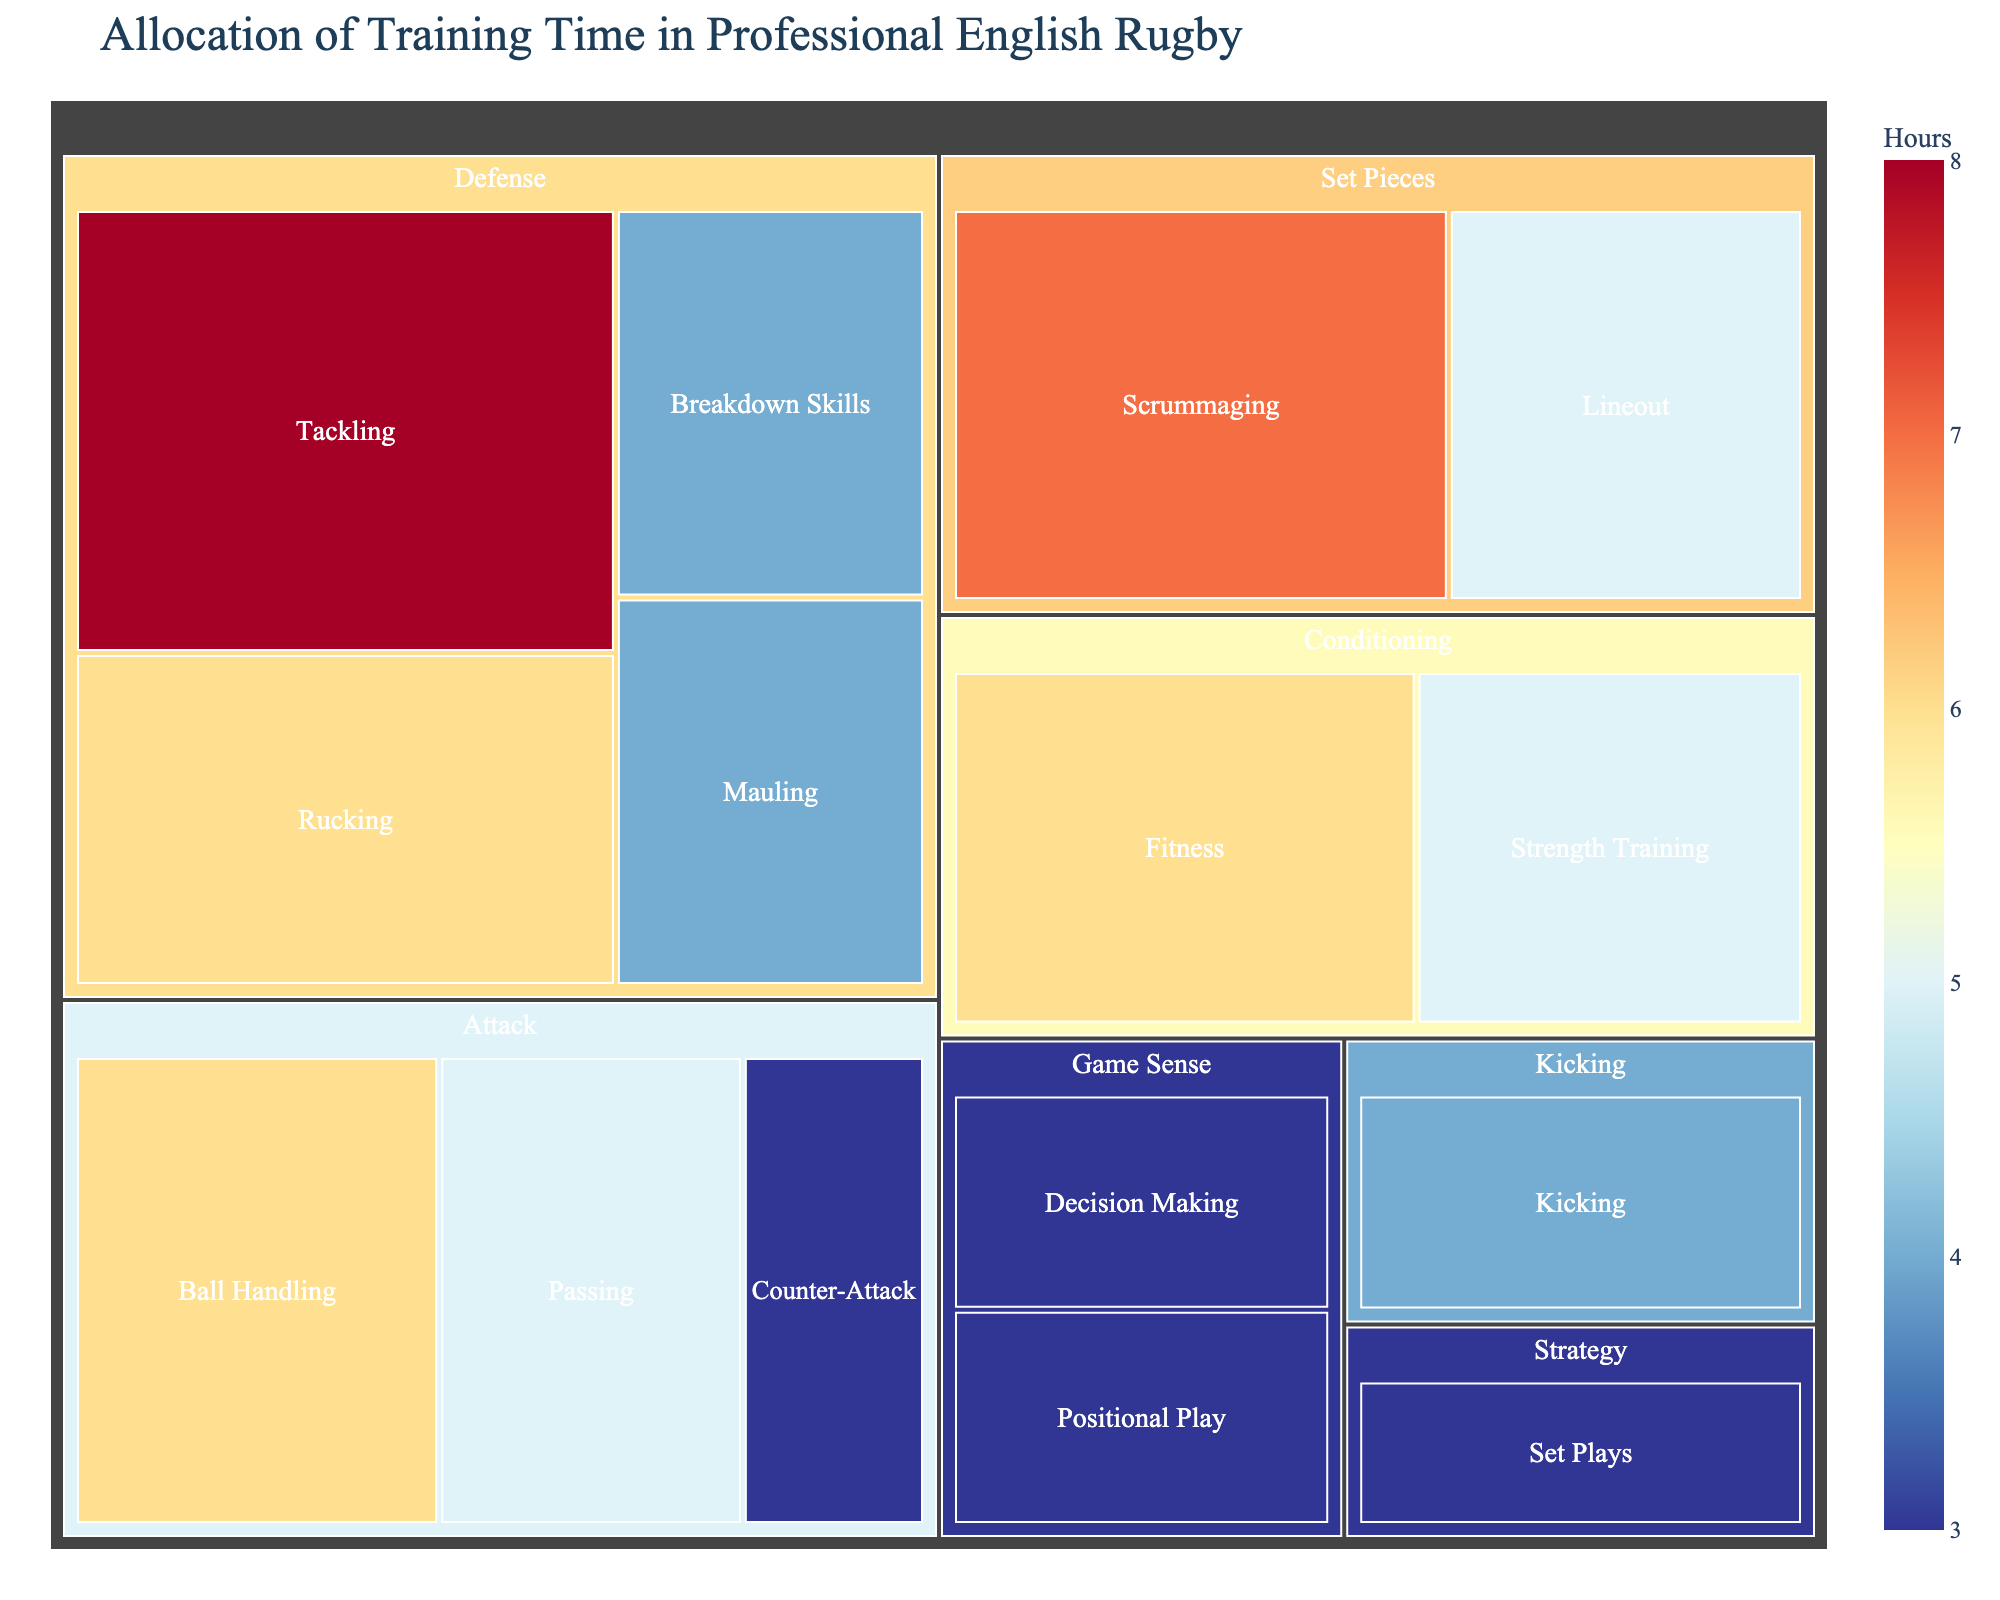what is the total training time spent on Defense skills? Add the hours for all the skills under the "Defense" category. Tackling (8) + Rucking (6) + Mauling (4) + Breakdown Skills (4) = 22
Answer: 22 Which skill receives the most training time? Look at all the skills and find the one with the highest value in hours. Tackling has 8 hours, which is more than any other skill.
Answer: Tackling Which category receives more training: Attack or Set Pieces? Sum the hours for all the skills in the "Attack" category and compare it to the sum in the "Set Pieces" category. Attack: Ball Handling (6) + Passing (5) + Counter-Attack (3) = 14; Set Pieces: Scrummaging (7) + Lineout (5) = 12. So, Attack receives more training.
Answer: Attack How does the training time for Strength Training compare to Kicking? Look at the hours for Strength Training (5) and Kicking (4). Strength Training has more hours than Kicking.
Answer: Strength Training has more hours How many hours are dedicated to Conditioning overall? Add the hours for all the skills under the "Conditioning" category. Fitness (6) + Strength Training (5) = 11
Answer: 11 What's the difference in training time between the most and least trained skills? Identify the most trained skill (Tackling, 8 hours) and least trained skill (Decision Making, Positional Play, Counter-Attack, and Set Plays, all with 3 hours). The difference is 8 - 3 = 5
Answer: 5 Which category has the widest range of training times among its skills? Compare the range (difference between maximum and minimum values) of hours in each category. Defense range: 8 - 4 = 4; Set Pieces range: 7 - 5 = 2; Attack range: 6 - 3 = 3; Kicking: only one skill; Game Sense range: 3 - 3 = 0; Conditioning range: 6 - 5 = 1; Strategy: only one skill. Defense has the widest range (4).
Answer: Defense Considering the Game Sense category, are the training times for Decision Making and Positional Play the same? Look specifically at the hours for Decision Making and Positional Play; both have 3 hours each.
Answer: Yes Which skill within the Set Pieces category is trained more? Compare the hours for Scrummaging (7) and Lineout (5); Scrummaging has more hours.
Answer: Scrummaging Is any skill within the Game Sense category allocated less training time than the Counter-Attack skill? Compare the hours for Decision Making (3) and Positional Play (3) with Counter-Attack (3). All three skills have equal hours allocated.
Answer: No 